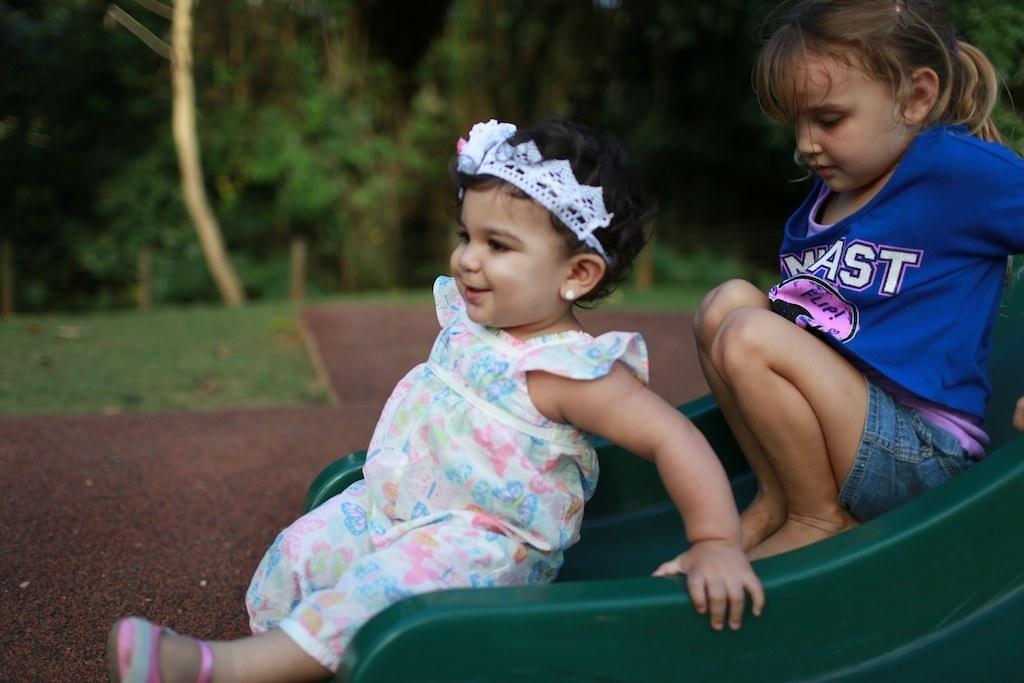Describe this image in one or two sentences. In this picture we can observe two girls sliding on the green color sliding board. One of the girl is smiling. In the background we can observe some trees. 